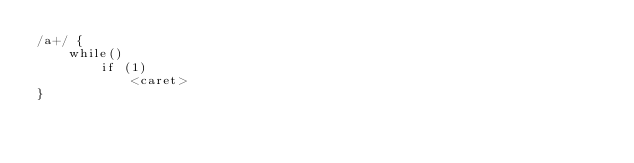<code> <loc_0><loc_0><loc_500><loc_500><_Awk_>/a+/ {
    while()
        if (1)
            <caret>
}</code> 